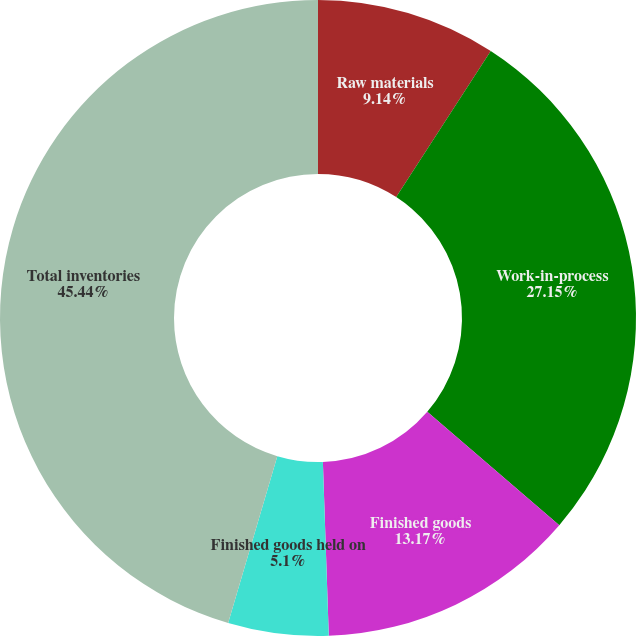<chart> <loc_0><loc_0><loc_500><loc_500><pie_chart><fcel>Raw materials<fcel>Work-in-process<fcel>Finished goods<fcel>Finished goods held on<fcel>Total inventories<nl><fcel>9.14%<fcel>27.15%<fcel>13.17%<fcel>5.1%<fcel>45.44%<nl></chart> 